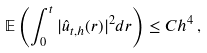Convert formula to latex. <formula><loc_0><loc_0><loc_500><loc_500>\mathbb { E } \left ( \int _ { 0 } ^ { t } | \hat { u } _ { t , h } ( r ) | ^ { 2 } d r \right ) \leq C h ^ { 4 } \, ,</formula> 